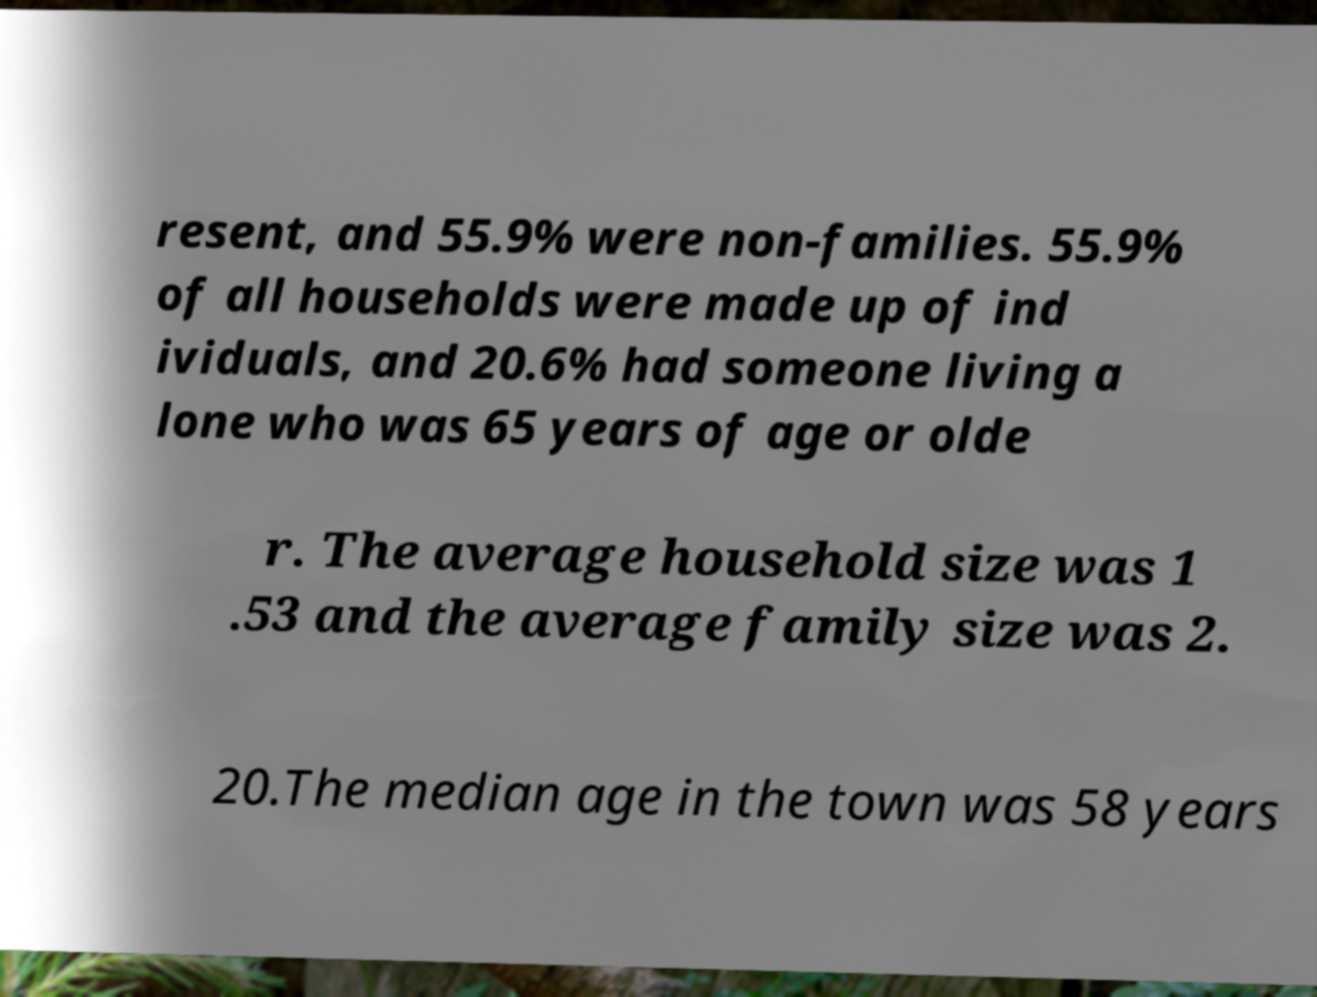For documentation purposes, I need the text within this image transcribed. Could you provide that? resent, and 55.9% were non-families. 55.9% of all households were made up of ind ividuals, and 20.6% had someone living a lone who was 65 years of age or olde r. The average household size was 1 .53 and the average family size was 2. 20.The median age in the town was 58 years 